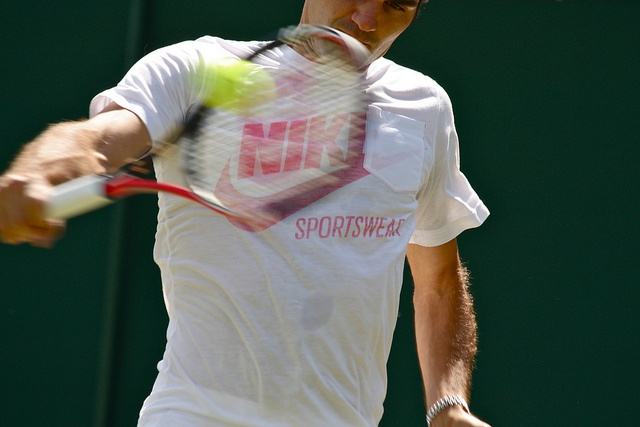Describe the objects in this image and their specific colors. I can see people in black, darkgray, white, brown, and tan tones, tennis racket in black, darkgray, and gray tones, and sports ball in black, khaki, olive, and tan tones in this image. 